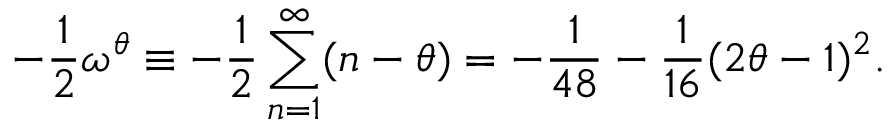Convert formula to latex. <formula><loc_0><loc_0><loc_500><loc_500>- \frac { 1 } { 2 } \omega ^ { \theta } \equiv - \frac { 1 } { 2 } \sum _ { n = 1 } ^ { \infty } ( n - \theta ) = - \frac { 1 } { 4 8 } - \frac { 1 } { 1 6 } ( 2 \theta - 1 ) ^ { 2 } .</formula> 